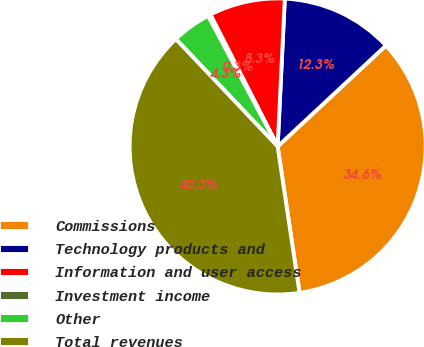<chart> <loc_0><loc_0><loc_500><loc_500><pie_chart><fcel>Commissions<fcel>Technology products and<fcel>Information and user access<fcel>Investment income<fcel>Other<fcel>Total revenues<nl><fcel>34.57%<fcel>12.29%<fcel>8.28%<fcel>0.28%<fcel>4.28%<fcel>40.29%<nl></chart> 